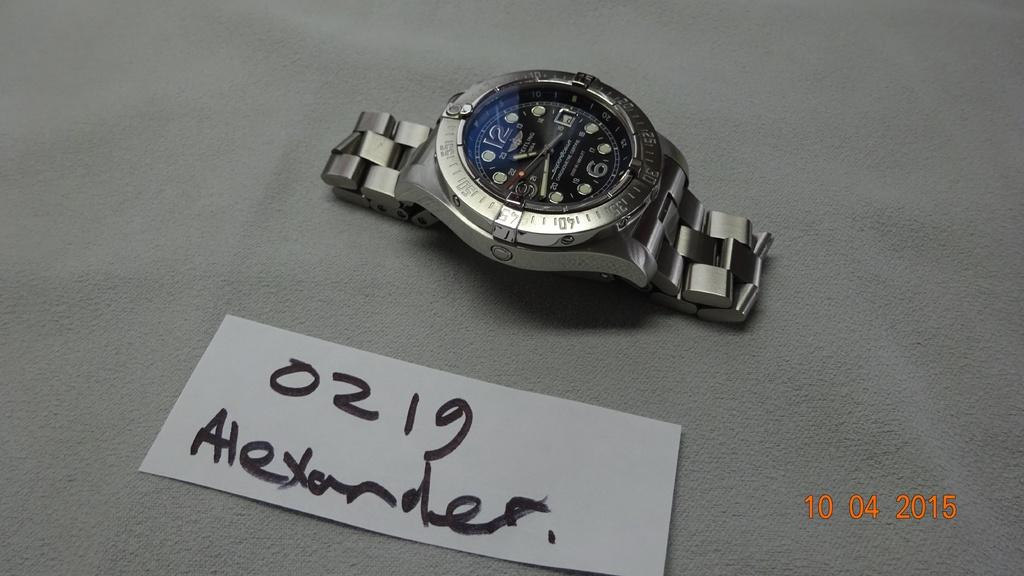<image>
Offer a succinct explanation of the picture presented. the watch is laying by a tag that says 0219 Alexander 